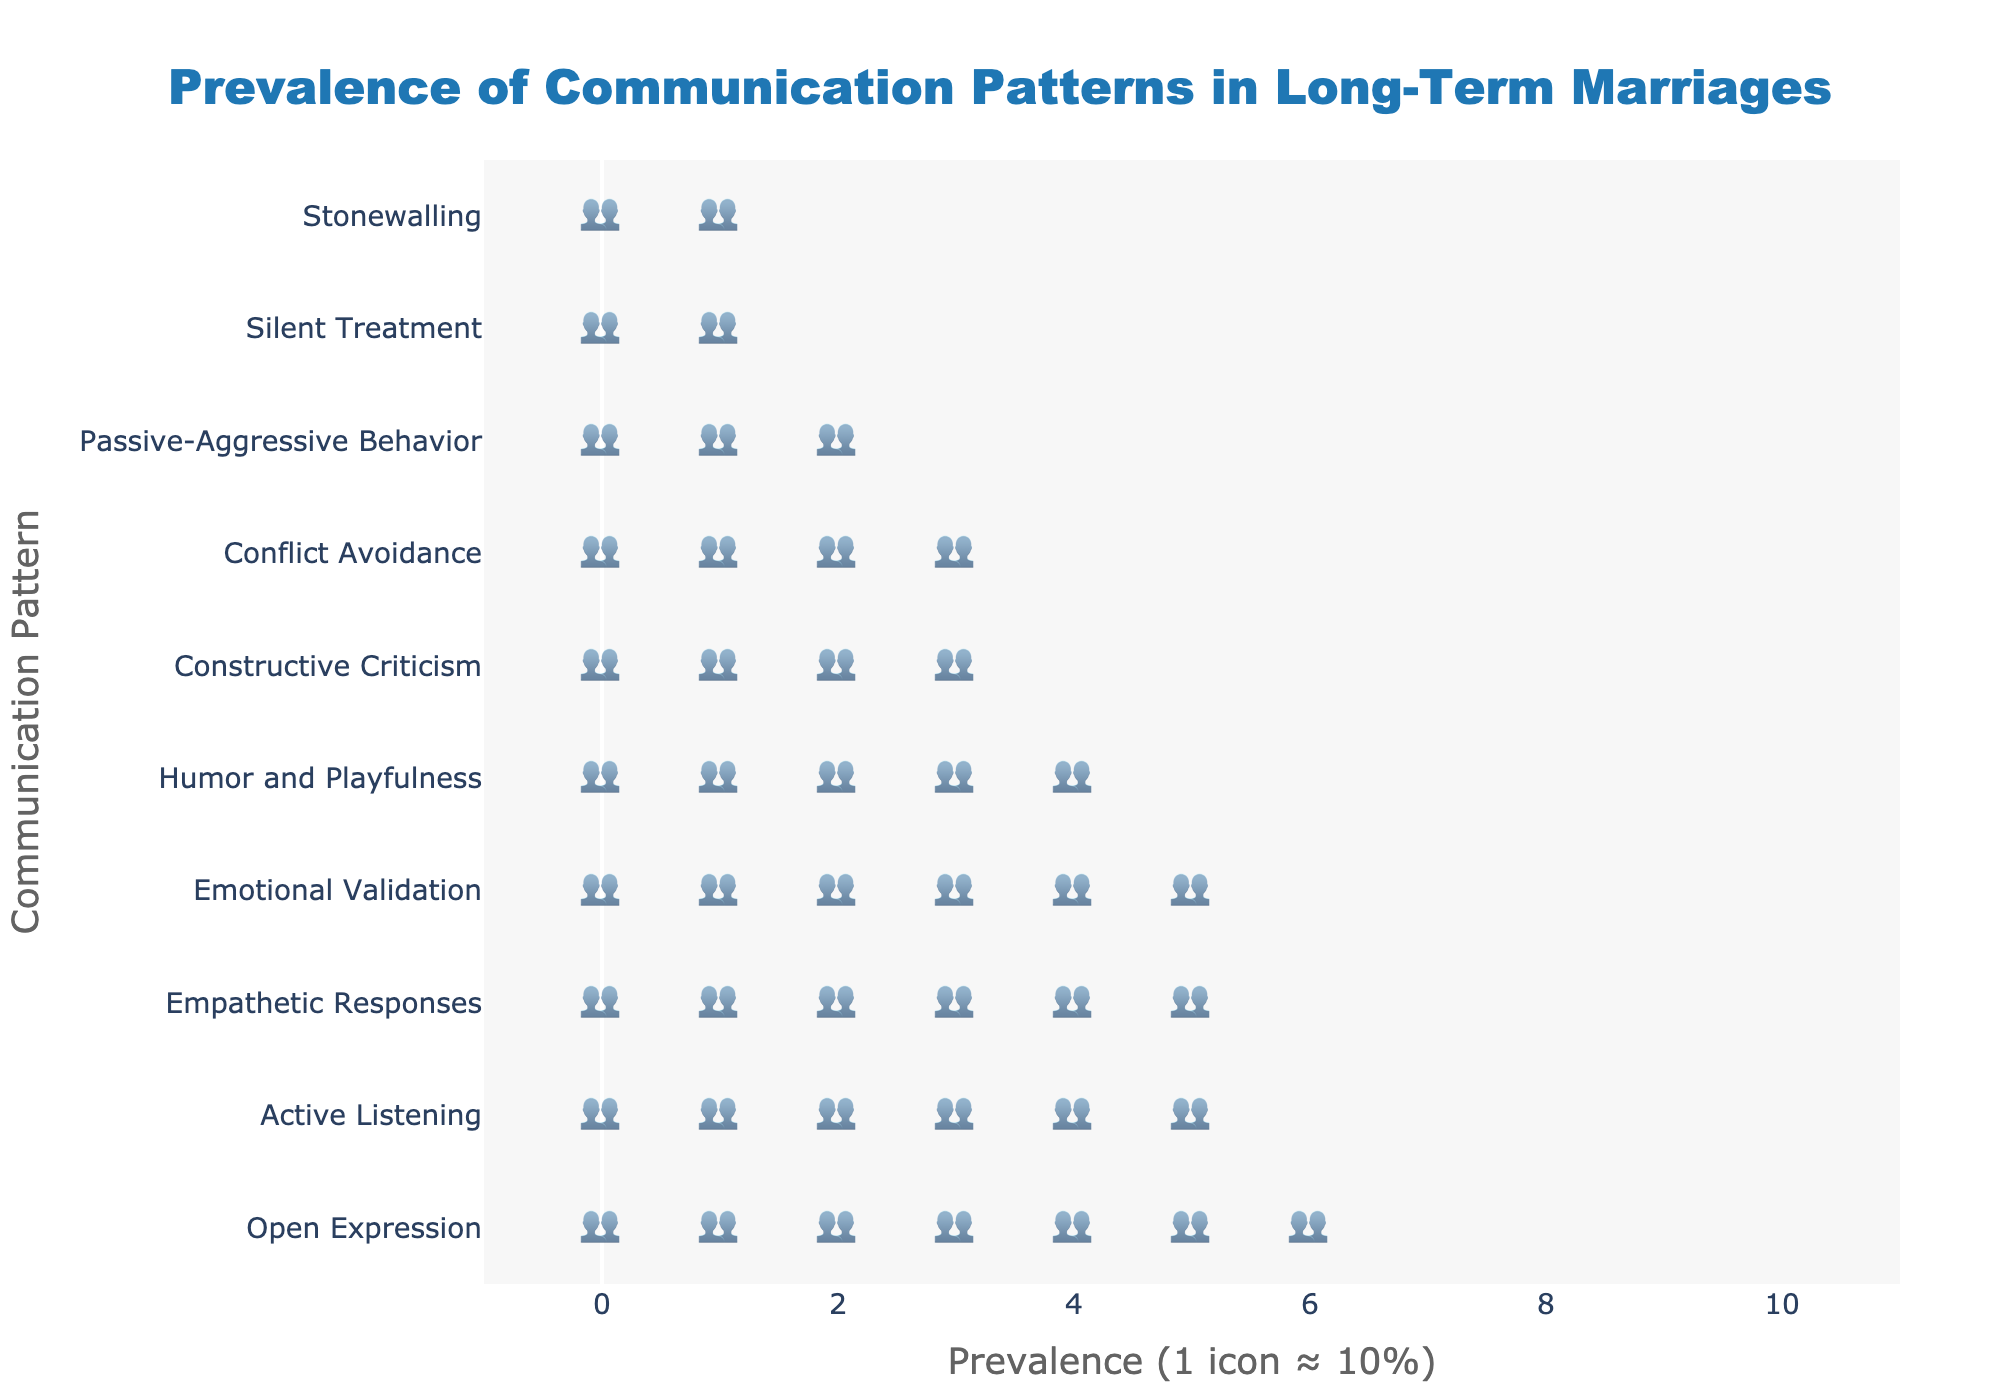What is the title of the figure? The title is the main text at the top of the figure, which provides a brief description of what the figure represents. In this case, it is centered and displayed at the top in a larger font.
Answer: Prevalence of Communication Patterns in Long-Term Marriages How many communication patterns are displayed in the figure? To find the number of communication patterns, count the unique items listed on the y-axis from top to bottom. Each item represents a different communication pattern.
Answer: 10 Which communication pattern has the highest prevalence among long-term married couples? Look at the y-axis to find the communication pattern with the most icons associated with it on the x-axis. The pattern with the most icons is at the top.
Answer: Open Expression What is the prevalence of Stonewalling? Find the row labeled "Stonewalling" on the y-axis and count the number of person icons (👥) in that row. Multiply by 10 to get the percentage prevalence.
Answer: 19% Which two communication patterns have the closest prevalence rates? Compare the number of icons for each communication pattern and identify two patterns that have a similar number of icons. The ones that match or are closest in count have the closest prevalence rates.
Answer: Constructive Criticism (42) and Conflict Avoidance (35) What is the sum of the prevalence rates for Emotional Validation and Empathetic Responses? Locate the rows for "Emotional Validation" and "Empathetic Responses", count the icons for each, multiply by 10, and add the results together (58 + 61).
Answer: 119% Which communication pattern has the lowest prevalence, and what is its rate? Find the pattern with the least number of person icons, which will be the last on the y-axis, and count the icons to determine its prevalence.
Answer: Stonewalling, 19% Is Active Listening or Humor and Playfulness more prevalent in long-term marriages? Compare the number of person icons in the rows for "Active Listening" and "Humor and Playfulness". The pattern with more icons is more prevalent.
Answer: Active Listening What is the average prevalence of all the communication patterns? Add up the prevalence percentages for all communication patterns, then divide by the total number of patterns. \(\frac{65 + 58 + 42 + 23 + 70 + 35 + 53 + 28 + 61 + 19}{10}\)
Answer: 45.4% How much more prevalent is Open Expression compared to Silent Treatment? Locate the rows for "Open Expression" and "Silent Treatment" and count the icons for each. Subtract the number of icons for Silent Treatment from Open Expression and multiply by 10.
Answer: 47% 